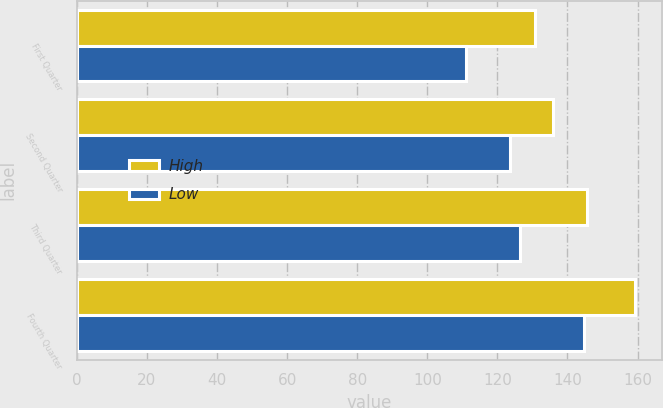Convert chart to OTSL. <chart><loc_0><loc_0><loc_500><loc_500><stacked_bar_chart><ecel><fcel>First Quarter<fcel>Second Quarter<fcel>Third Quarter<fcel>Fourth Quarter<nl><fcel>High<fcel>130.64<fcel>135.97<fcel>145.51<fcel>159.13<nl><fcel>Low<fcel>110.91<fcel>123.65<fcel>126.36<fcel>144.81<nl></chart> 